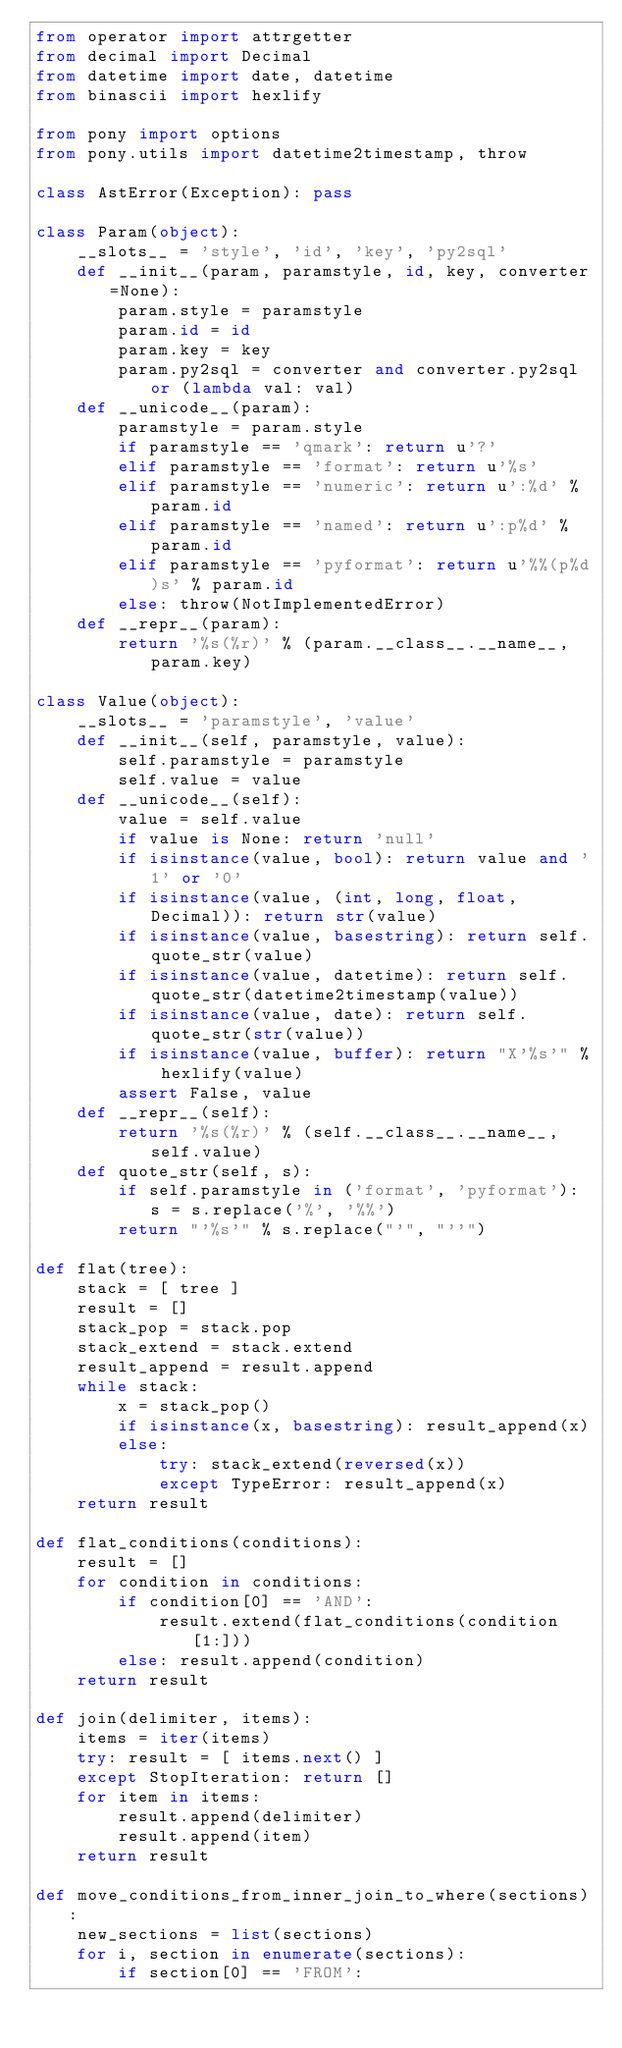Convert code to text. <code><loc_0><loc_0><loc_500><loc_500><_Python_>from operator import attrgetter
from decimal import Decimal
from datetime import date, datetime
from binascii import hexlify

from pony import options
from pony.utils import datetime2timestamp, throw

class AstError(Exception): pass

class Param(object):
    __slots__ = 'style', 'id', 'key', 'py2sql'
    def __init__(param, paramstyle, id, key, converter=None):
        param.style = paramstyle
        param.id = id
        param.key = key
        param.py2sql = converter and converter.py2sql or (lambda val: val)
    def __unicode__(param):
        paramstyle = param.style
        if paramstyle == 'qmark': return u'?'
        elif paramstyle == 'format': return u'%s'
        elif paramstyle == 'numeric': return u':%d' % param.id
        elif paramstyle == 'named': return u':p%d' % param.id
        elif paramstyle == 'pyformat': return u'%%(p%d)s' % param.id
        else: throw(NotImplementedError)
    def __repr__(param):
        return '%s(%r)' % (param.__class__.__name__, param.key)

class Value(object):
    __slots__ = 'paramstyle', 'value'
    def __init__(self, paramstyle, value):
        self.paramstyle = paramstyle
        self.value = value
    def __unicode__(self):
        value = self.value
        if value is None: return 'null'
        if isinstance(value, bool): return value and '1' or '0'
        if isinstance(value, (int, long, float, Decimal)): return str(value)
        if isinstance(value, basestring): return self.quote_str(value)
        if isinstance(value, datetime): return self.quote_str(datetime2timestamp(value))
        if isinstance(value, date): return self.quote_str(str(value))
        if isinstance(value, buffer): return "X'%s'" % hexlify(value)
        assert False, value
    def __repr__(self):
        return '%s(%r)' % (self.__class__.__name__, self.value)
    def quote_str(self, s):
        if self.paramstyle in ('format', 'pyformat'): s = s.replace('%', '%%')
        return "'%s'" % s.replace("'", "''")

def flat(tree):
    stack = [ tree ]
    result = []
    stack_pop = stack.pop
    stack_extend = stack.extend
    result_append = result.append
    while stack:
        x = stack_pop()
        if isinstance(x, basestring): result_append(x)
        else:
            try: stack_extend(reversed(x))
            except TypeError: result_append(x)
    return result

def flat_conditions(conditions):
    result = []
    for condition in conditions:
        if condition[0] == 'AND':
            result.extend(flat_conditions(condition[1:]))
        else: result.append(condition)
    return result

def join(delimiter, items):
    items = iter(items)
    try: result = [ items.next() ]
    except StopIteration: return []
    for item in items:
        result.append(delimiter)
        result.append(item)
    return result

def move_conditions_from_inner_join_to_where(sections):
    new_sections = list(sections)
    for i, section in enumerate(sections):
        if section[0] == 'FROM':</code> 